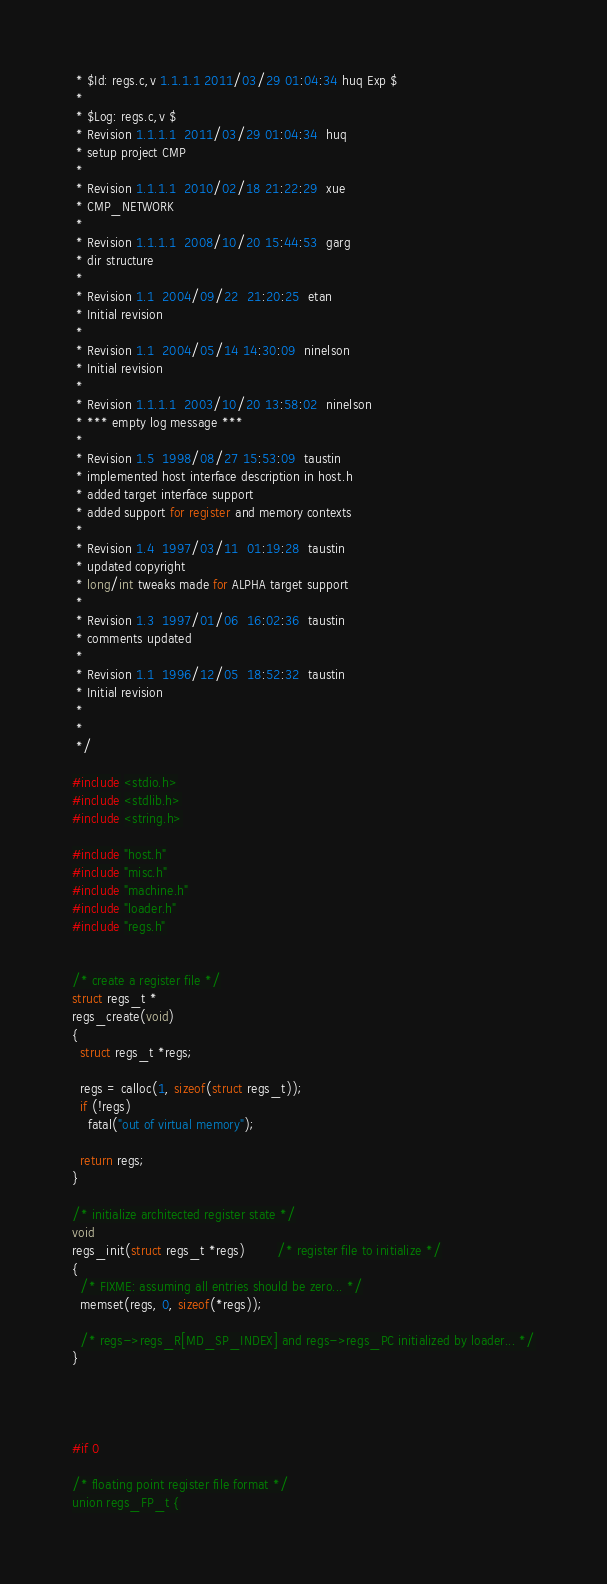<code> <loc_0><loc_0><loc_500><loc_500><_C_> * $Id: regs.c,v 1.1.1.1 2011/03/29 01:04:34 huq Exp $
 *
 * $Log: regs.c,v $
 * Revision 1.1.1.1  2011/03/29 01:04:34  huq
 * setup project CMP
 *
 * Revision 1.1.1.1  2010/02/18 21:22:29  xue
 * CMP_NETWORK
 *
 * Revision 1.1.1.1  2008/10/20 15:44:53  garg
 * dir structure
 *
 * Revision 1.1  2004/09/22  21:20:25  etan
 * Initial revision
 *
 * Revision 1.1  2004/05/14 14:30:09  ninelson
 * Initial revision
 *
 * Revision 1.1.1.1  2003/10/20 13:58:02  ninelson
 * *** empty log message ***
 *
 * Revision 1.5  1998/08/27 15:53:09  taustin
 * implemented host interface description in host.h
 * added target interface support
 * added support for register and memory contexts
 *
 * Revision 1.4  1997/03/11  01:19:28  taustin
 * updated copyright
 * long/int tweaks made for ALPHA target support
 *
 * Revision 1.3  1997/01/06  16:02:36  taustin
 * comments updated
 *
 * Revision 1.1  1996/12/05  18:52:32  taustin
 * Initial revision
 *
 *
 */

#include <stdio.h>
#include <stdlib.h>
#include <string.h>

#include "host.h"
#include "misc.h"
#include "machine.h"
#include "loader.h"
#include "regs.h"


/* create a register file */
struct regs_t *
regs_create(void)
{
  struct regs_t *regs;

  regs = calloc(1, sizeof(struct regs_t));
  if (!regs)
    fatal("out of virtual memory");

  return regs;
}

/* initialize architected register state */
void
regs_init(struct regs_t *regs)		/* register file to initialize */
{
  /* FIXME: assuming all entries should be zero... */
  memset(regs, 0, sizeof(*regs));

  /* regs->regs_R[MD_SP_INDEX] and regs->regs_PC initialized by loader... */
}




#if 0

/* floating point register file format */
union regs_FP_t {</code> 